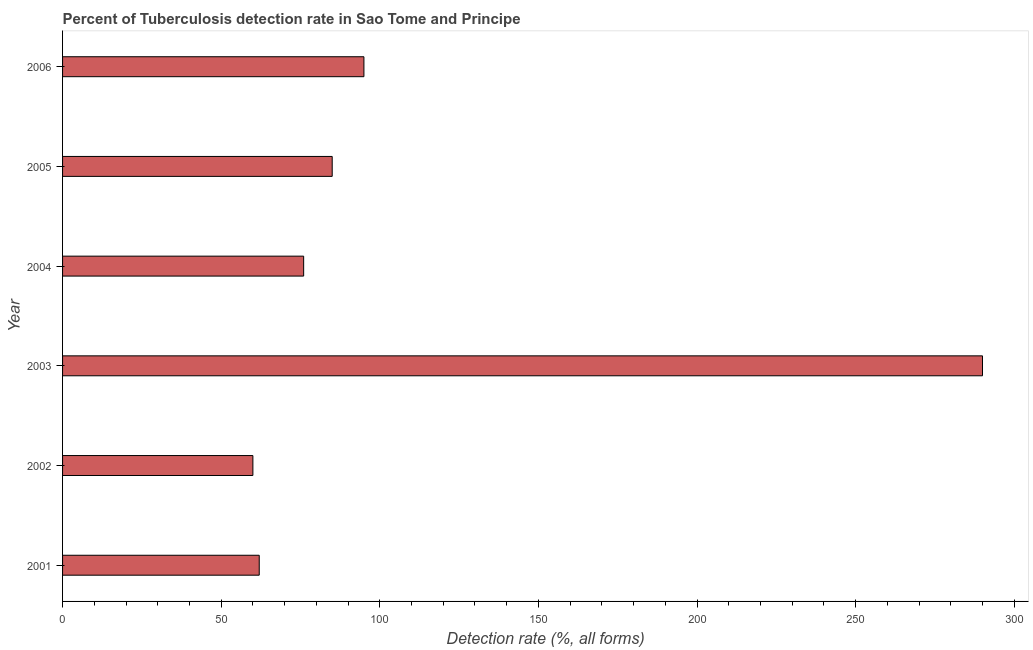Does the graph contain grids?
Keep it short and to the point. No. What is the title of the graph?
Your answer should be compact. Percent of Tuberculosis detection rate in Sao Tome and Principe. What is the label or title of the X-axis?
Provide a short and direct response. Detection rate (%, all forms). What is the label or title of the Y-axis?
Your answer should be very brief. Year. What is the detection rate of tuberculosis in 2006?
Offer a very short reply. 95. Across all years, what is the maximum detection rate of tuberculosis?
Provide a succinct answer. 290. In which year was the detection rate of tuberculosis minimum?
Provide a short and direct response. 2002. What is the sum of the detection rate of tuberculosis?
Your answer should be compact. 668. What is the difference between the detection rate of tuberculosis in 2003 and 2004?
Ensure brevity in your answer.  214. What is the average detection rate of tuberculosis per year?
Ensure brevity in your answer.  111. What is the median detection rate of tuberculosis?
Your answer should be very brief. 80.5. What is the ratio of the detection rate of tuberculosis in 2002 to that in 2006?
Offer a terse response. 0.63. Is the detection rate of tuberculosis in 2003 less than that in 2005?
Your response must be concise. No. What is the difference between the highest and the second highest detection rate of tuberculosis?
Your answer should be compact. 195. Is the sum of the detection rate of tuberculosis in 2001 and 2004 greater than the maximum detection rate of tuberculosis across all years?
Offer a terse response. No. What is the difference between the highest and the lowest detection rate of tuberculosis?
Ensure brevity in your answer.  230. In how many years, is the detection rate of tuberculosis greater than the average detection rate of tuberculosis taken over all years?
Provide a short and direct response. 1. How many bars are there?
Offer a terse response. 6. What is the difference between two consecutive major ticks on the X-axis?
Offer a terse response. 50. What is the Detection rate (%, all forms) of 2001?
Make the answer very short. 62. What is the Detection rate (%, all forms) in 2002?
Your answer should be compact. 60. What is the Detection rate (%, all forms) in 2003?
Make the answer very short. 290. What is the Detection rate (%, all forms) of 2006?
Your answer should be very brief. 95. What is the difference between the Detection rate (%, all forms) in 2001 and 2003?
Your answer should be very brief. -228. What is the difference between the Detection rate (%, all forms) in 2001 and 2006?
Give a very brief answer. -33. What is the difference between the Detection rate (%, all forms) in 2002 and 2003?
Keep it short and to the point. -230. What is the difference between the Detection rate (%, all forms) in 2002 and 2006?
Keep it short and to the point. -35. What is the difference between the Detection rate (%, all forms) in 2003 and 2004?
Your answer should be compact. 214. What is the difference between the Detection rate (%, all forms) in 2003 and 2005?
Keep it short and to the point. 205. What is the difference between the Detection rate (%, all forms) in 2003 and 2006?
Your answer should be very brief. 195. What is the difference between the Detection rate (%, all forms) in 2004 and 2005?
Offer a terse response. -9. What is the difference between the Detection rate (%, all forms) in 2005 and 2006?
Provide a short and direct response. -10. What is the ratio of the Detection rate (%, all forms) in 2001 to that in 2002?
Provide a short and direct response. 1.03. What is the ratio of the Detection rate (%, all forms) in 2001 to that in 2003?
Your answer should be compact. 0.21. What is the ratio of the Detection rate (%, all forms) in 2001 to that in 2004?
Offer a terse response. 0.82. What is the ratio of the Detection rate (%, all forms) in 2001 to that in 2005?
Your response must be concise. 0.73. What is the ratio of the Detection rate (%, all forms) in 2001 to that in 2006?
Give a very brief answer. 0.65. What is the ratio of the Detection rate (%, all forms) in 2002 to that in 2003?
Your answer should be compact. 0.21. What is the ratio of the Detection rate (%, all forms) in 2002 to that in 2004?
Provide a succinct answer. 0.79. What is the ratio of the Detection rate (%, all forms) in 2002 to that in 2005?
Provide a succinct answer. 0.71. What is the ratio of the Detection rate (%, all forms) in 2002 to that in 2006?
Provide a short and direct response. 0.63. What is the ratio of the Detection rate (%, all forms) in 2003 to that in 2004?
Your answer should be compact. 3.82. What is the ratio of the Detection rate (%, all forms) in 2003 to that in 2005?
Your response must be concise. 3.41. What is the ratio of the Detection rate (%, all forms) in 2003 to that in 2006?
Ensure brevity in your answer.  3.05. What is the ratio of the Detection rate (%, all forms) in 2004 to that in 2005?
Your answer should be very brief. 0.89. What is the ratio of the Detection rate (%, all forms) in 2005 to that in 2006?
Your response must be concise. 0.9. 